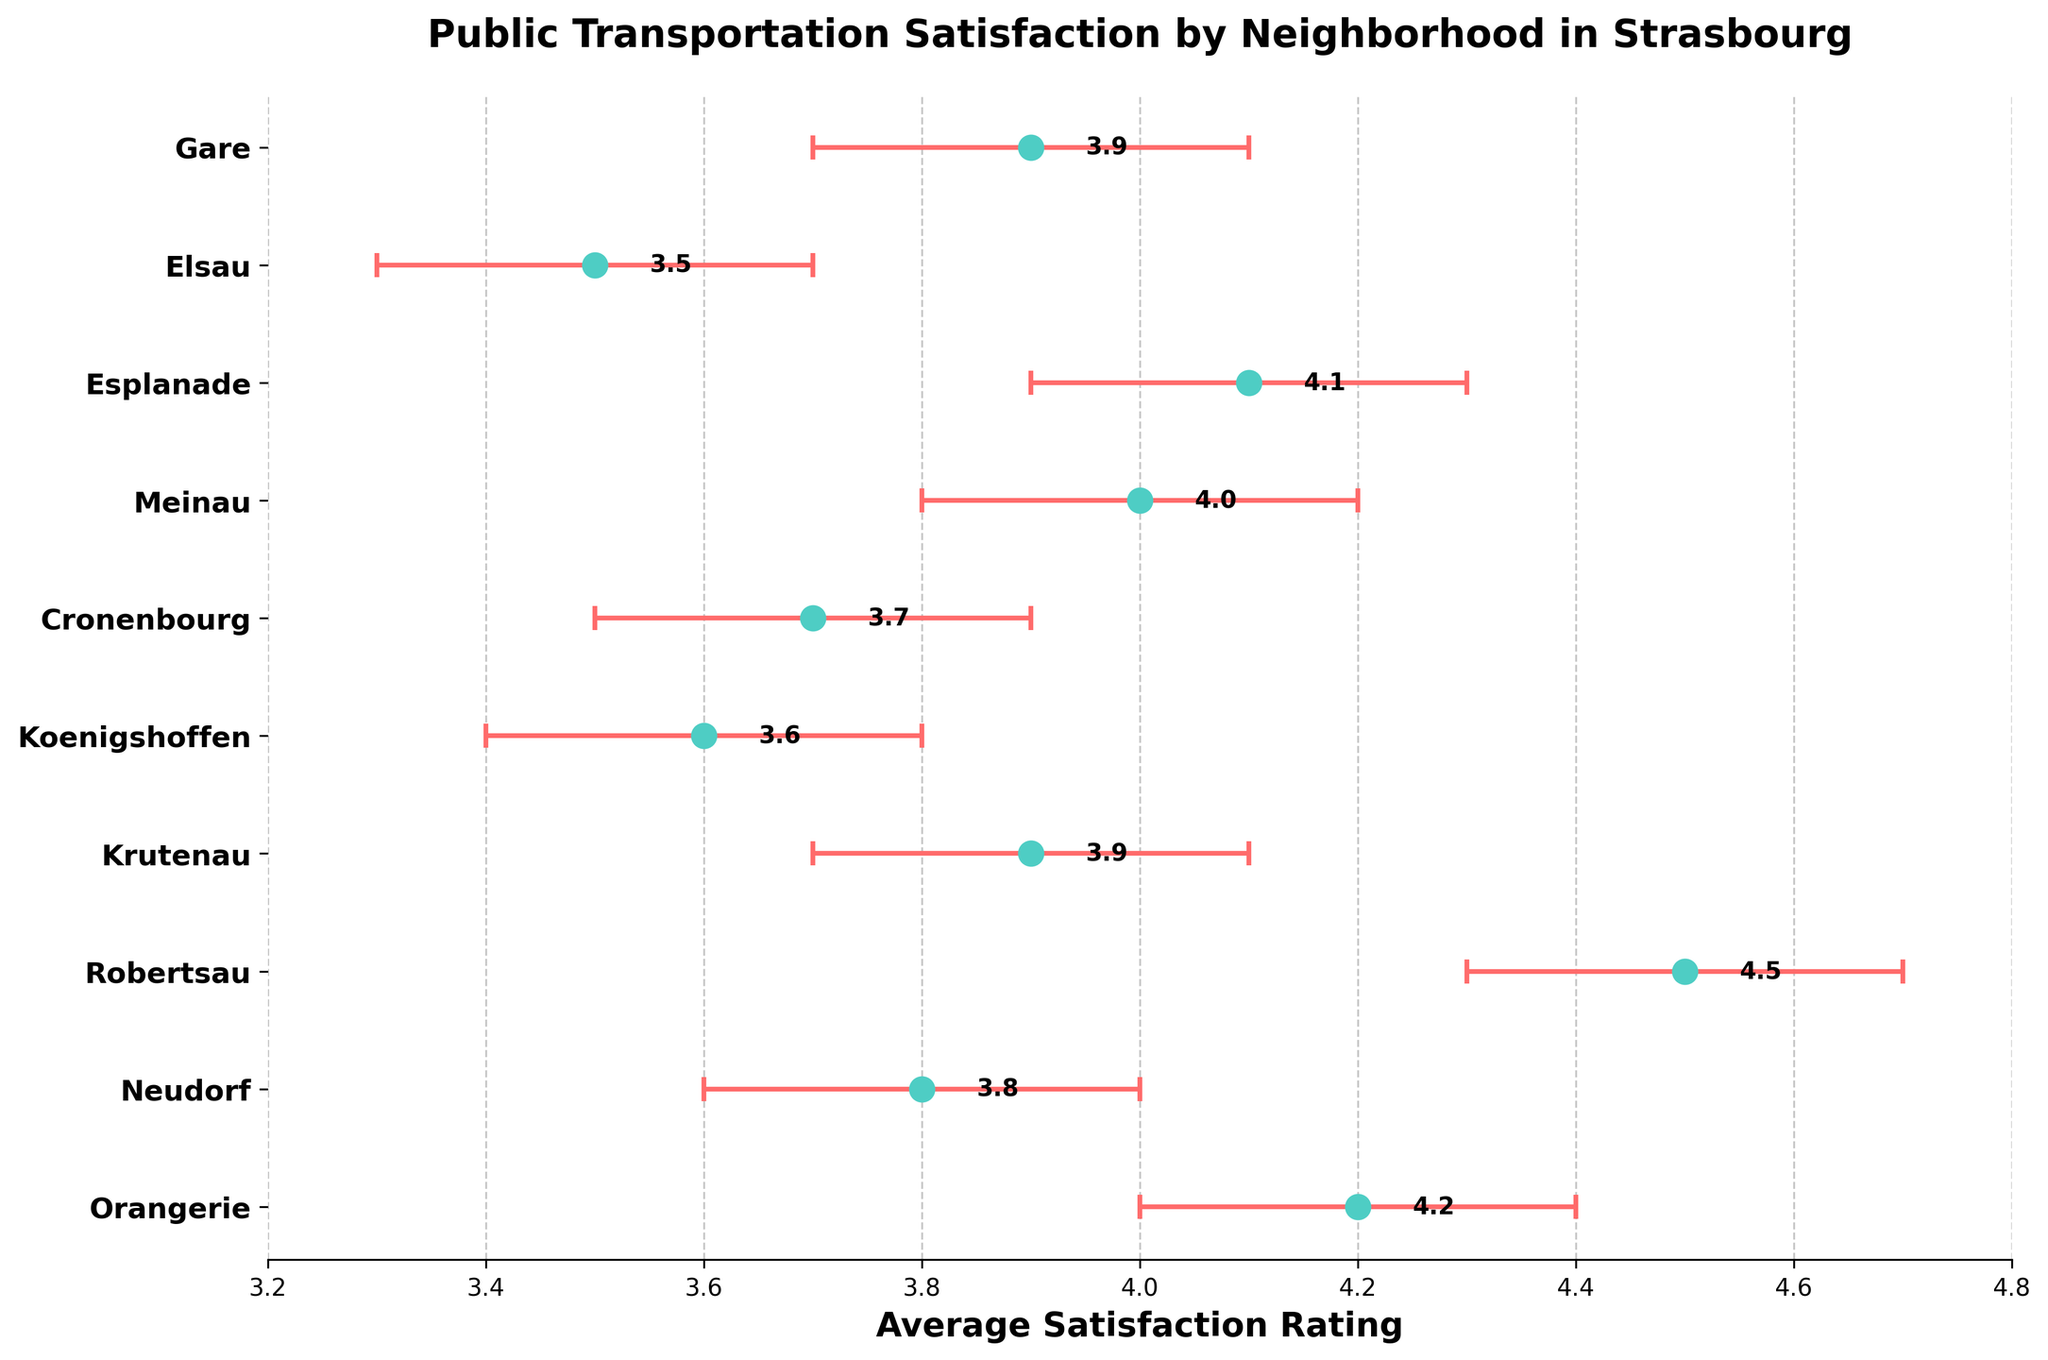What is the title of the figure? The title is usually the largest text and located at the top, which summarizes the content of the figure. The title of this figure is "Public Transportation Satisfaction by Neighborhood in Strasbourg."
Answer: Public Transportation Satisfaction by Neighborhood in Strasbourg What neighborhood has the highest average satisfaction rating? By looking at the positions of the dots, the highest dot represents the neighborhood with the highest average satisfaction. Robertsau has the highest average satisfaction rating of 4.5.
Answer: Robertsau Which neighborhoods have average satisfaction ratings lower than 4.0? The neighborhoods with dots positioned below the 4.0 mark on the x-axis have satisfaction ratings lower than 4.0. These neighborhoods are Neudorf, Koenigshoffen, Cronenbourg, and Elsau.
Answer: Neudorf, Koenigshoffen, Cronenbourg, Elsau How many neighborhoods have average satisfaction ratings above 4.0? Count the number of dots positioned above the 4.0 mark on the x-axis to find the neighborhoods with ratings higher than 4.0. There are 5 such neighborhoods.
Answer: 5 What is the range of the confidence interval for Krutenau? The confidence interval range can be found by subtracting the lower bound from the upper bound. For Krutenau, the lower confidence interval is 3.7, and the upper confidence interval is 4.1. The range is 4.1 - 3.7 = 0.4.
Answer: 0.4 Compare the satisfaction ratings of Orangerie and Gare. Which is higher? By comparing the positions of the dots for Orangerie and Gare on the x-axis, we see that Orangerie's dot (4.2) is positioned slightly to the right of Gare's dot (3.9), indicating that Orangerie's average satisfaction rating is higher.
Answer: Orangerie Which neighborhood has the widest confidence interval? The neighborhood with the widest confidence interval will have the longest error bars. By looking at the length of error bars, we find that Elsau, with confidence interval bounds from 3.3 to 3.7, has a range of 0.4, which is the same as several others. However, among the longest, it's one of the neighborhoods that have differential ranges of 0.4 excluding neighborhoods like Krutenau. For finality, these ranges across multiple neighborhoods are equal in length observed similar in wide spacing.
Answer: Elsau/Krutenau If we consider an average satisfaction rating of 3.9 as a benchmark, how many neighborhoods exceed this benchmark? Individual dots positioned to the right of the 3.9 mark on the x-axis indicate higher satisfaction ratings. Therefore, count the neighborhoods whose average satisfaction rating is greater than 3.9: Orangerie, Robertsau, Meinau, and Esplanade, totaling 4 neighborhoods.
Answer: 4 What is the satisfaction rating range (from lowest to highest) displayed in the figure? The lowest satisfaction rating is for Elsau at 3.5, and the highest is for Robertsau at 4.5. Thus, the range is from 3.5 to 4.5.
Answer: 3.5 to 4.5 